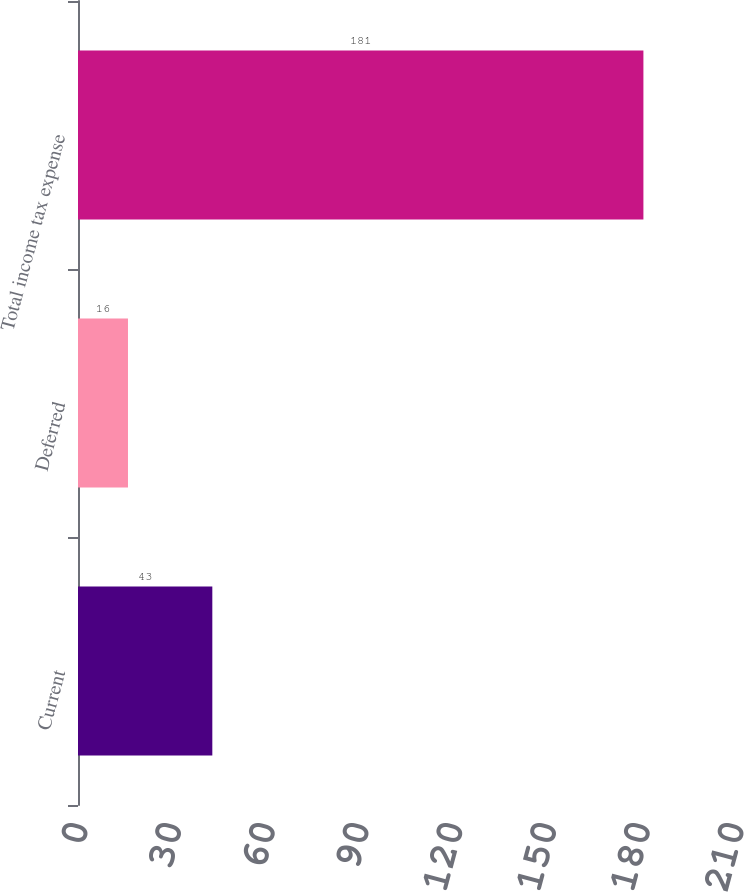<chart> <loc_0><loc_0><loc_500><loc_500><bar_chart><fcel>Current<fcel>Deferred<fcel>Total income tax expense<nl><fcel>43<fcel>16<fcel>181<nl></chart> 